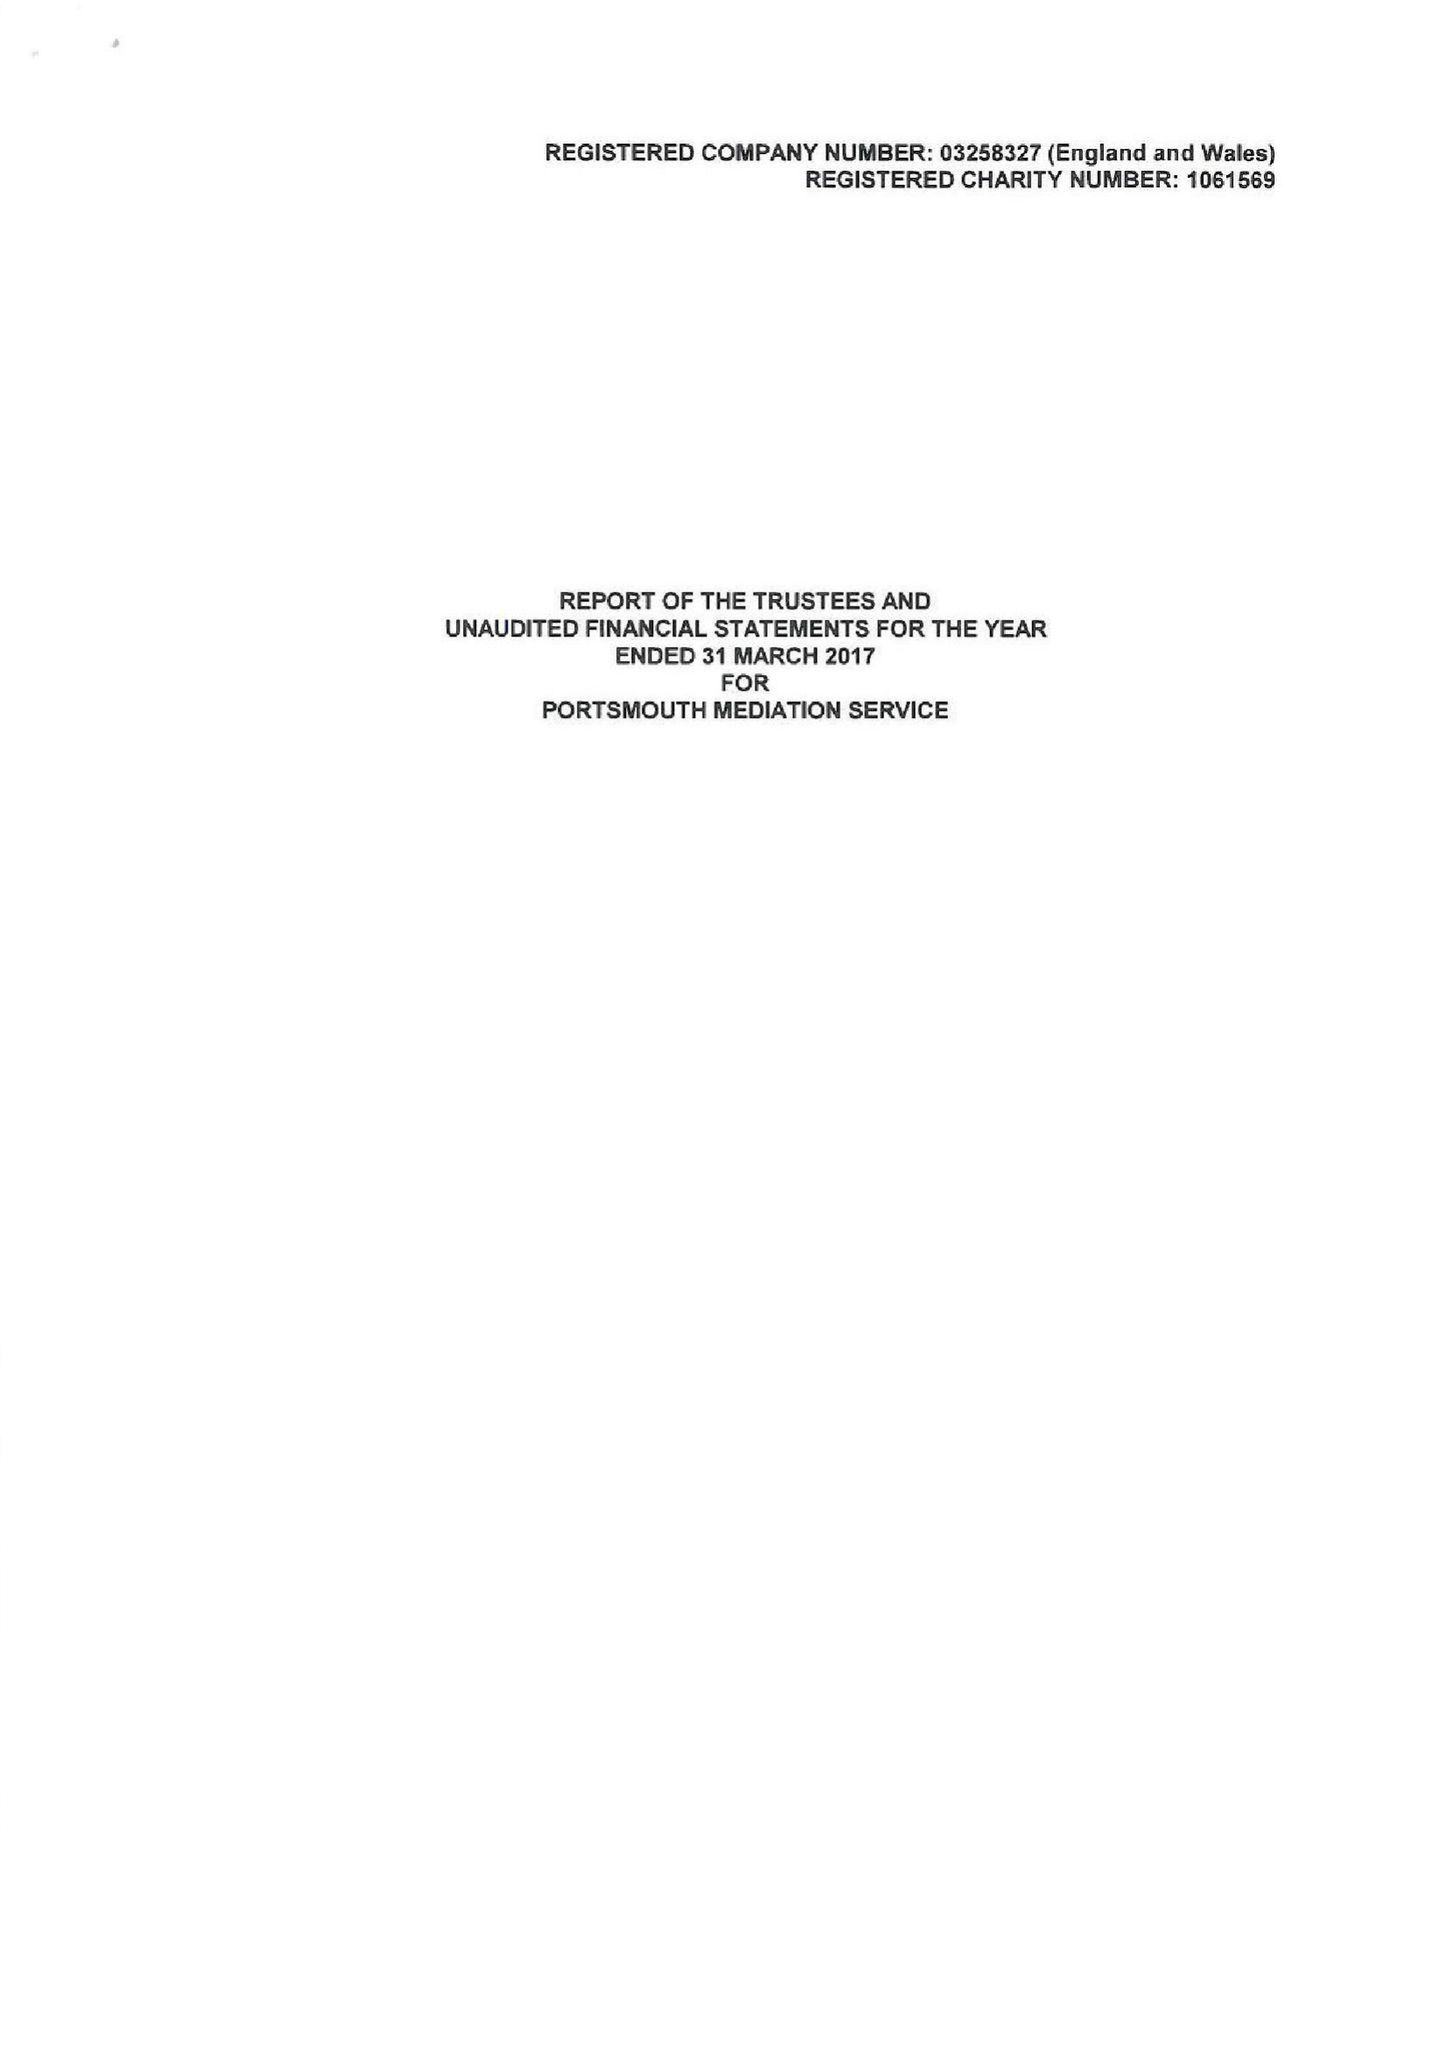What is the value for the report_date?
Answer the question using a single word or phrase. 2017-03-31 